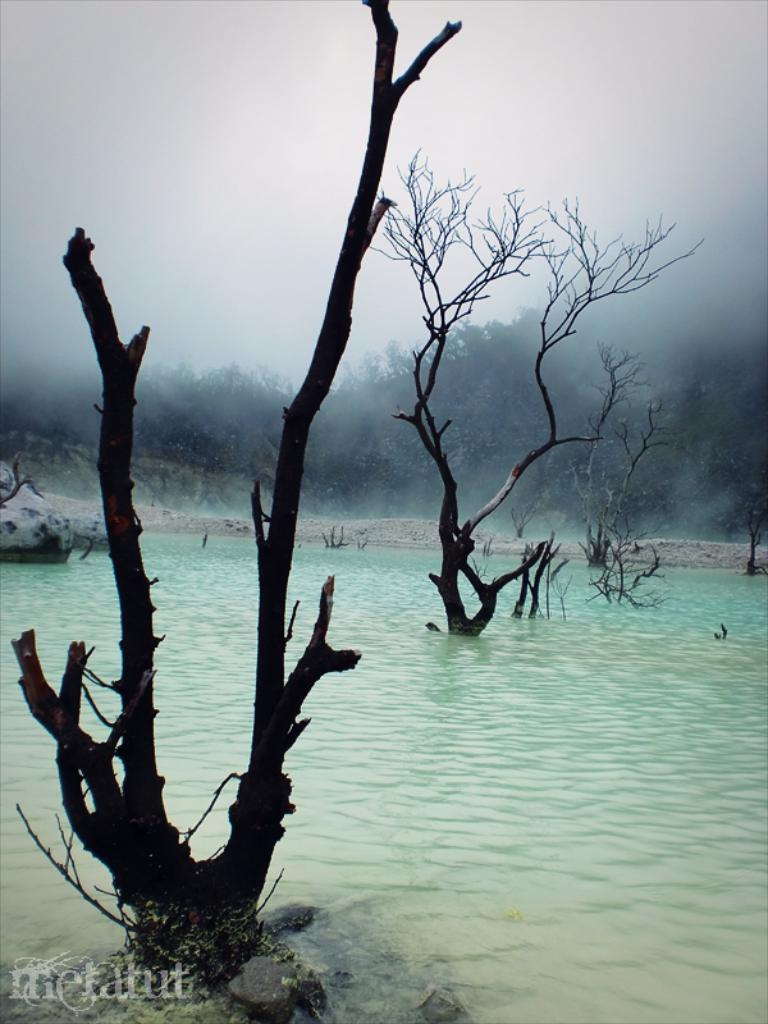What type of vegetation can be seen in the image? There are trees in the image. What natural element is visible in the image besides the trees? There is water visible in the image. How would you describe the sky in the image? The sky appears to be cloudy in the image. Can you identify any additional features on the image? Yes, there is a watermark on the left side bottom of the image. What type of hammer can be seen in the image? There is no hammer present in the image. Can you describe the teeth of the trees in the image? The image does not show the trees' teeth, as trees do not have teeth. 